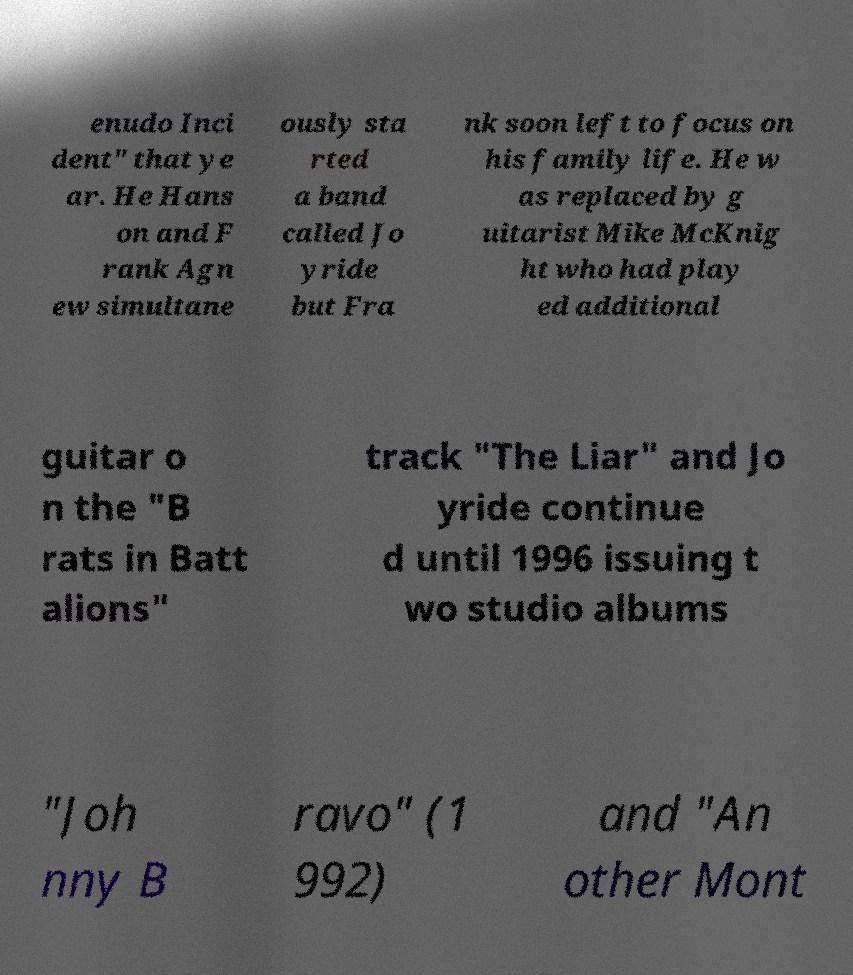For documentation purposes, I need the text within this image transcribed. Could you provide that? enudo Inci dent" that ye ar. He Hans on and F rank Agn ew simultane ously sta rted a band called Jo yride but Fra nk soon left to focus on his family life. He w as replaced by g uitarist Mike McKnig ht who had play ed additional guitar o n the "B rats in Batt alions" track "The Liar" and Jo yride continue d until 1996 issuing t wo studio albums "Joh nny B ravo" (1 992) and "An other Mont 